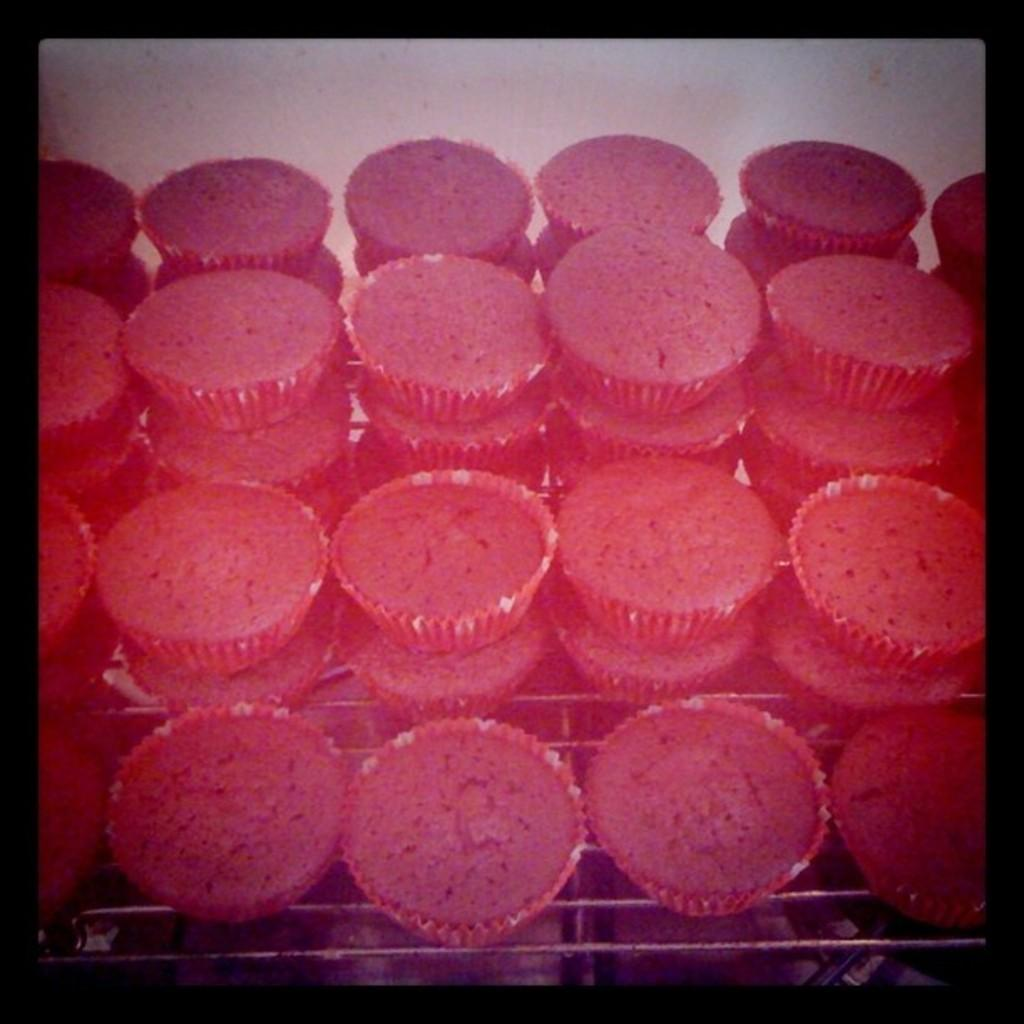What type of baked goods can be seen in the image? There are pink cupcakes in the image. How are the cupcakes arranged? The cupcakes are arranged in the image. What type of wilderness can be seen in the background of the image? There is no wilderness present in the image; it only features pink cupcakes. What type of business is being conducted in the image? There is no business being conducted in the image; it only features pink cupcakes. 